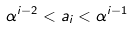<formula> <loc_0><loc_0><loc_500><loc_500>\alpha ^ { i - 2 } < a _ { i } < \alpha ^ { i - 1 }</formula> 